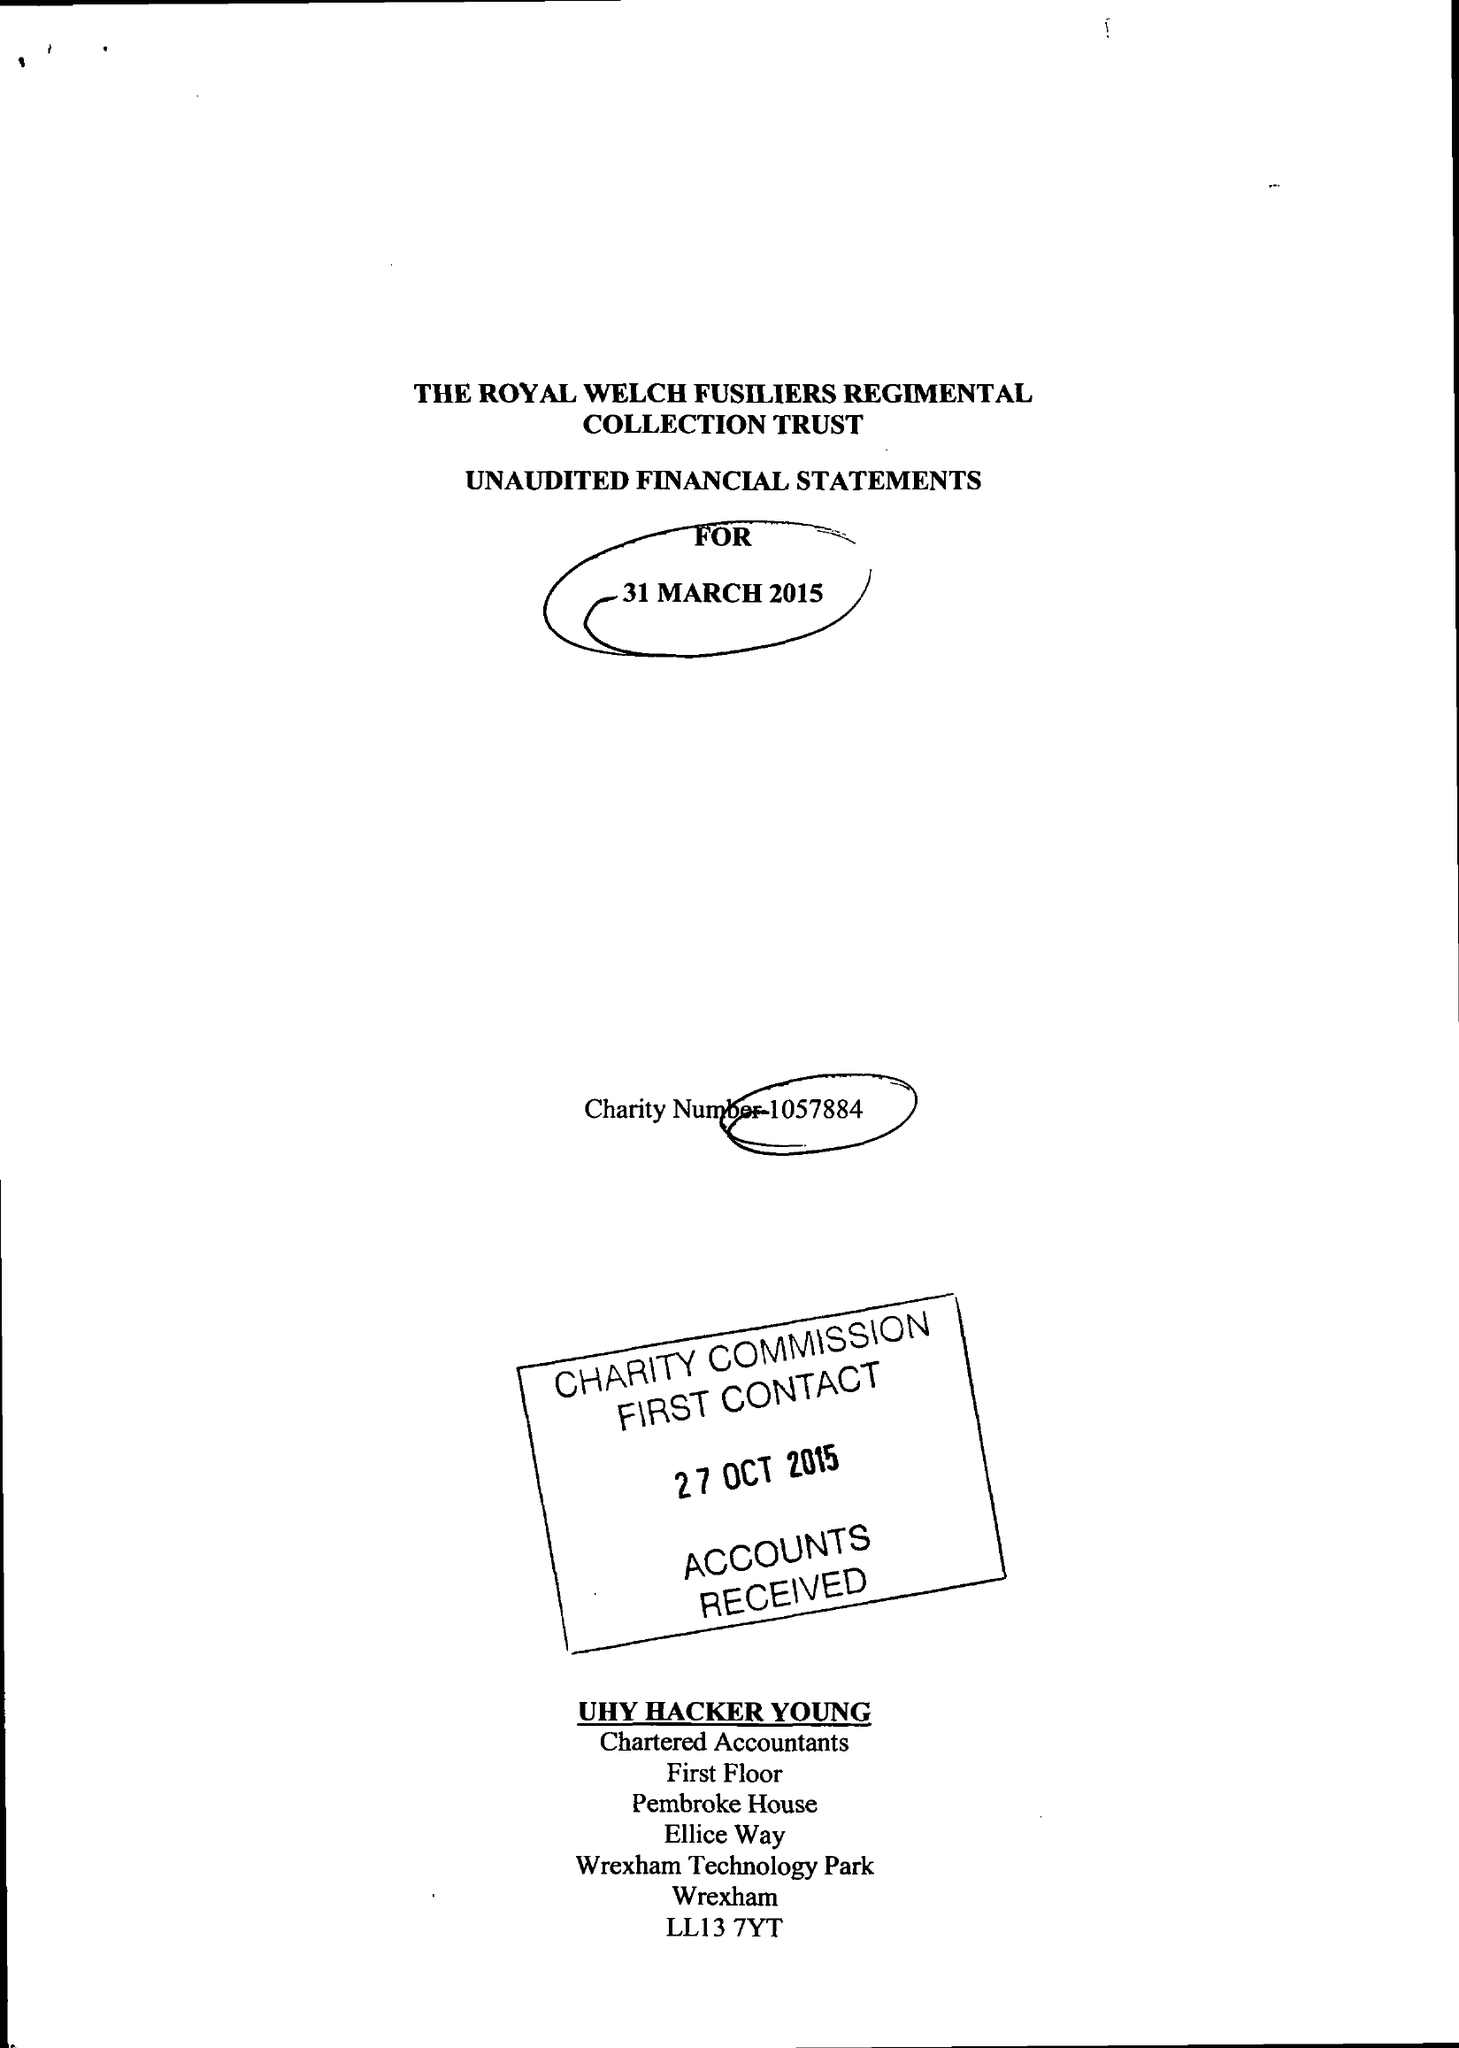What is the value for the charity_number?
Answer the question using a single word or phrase. 1057884 